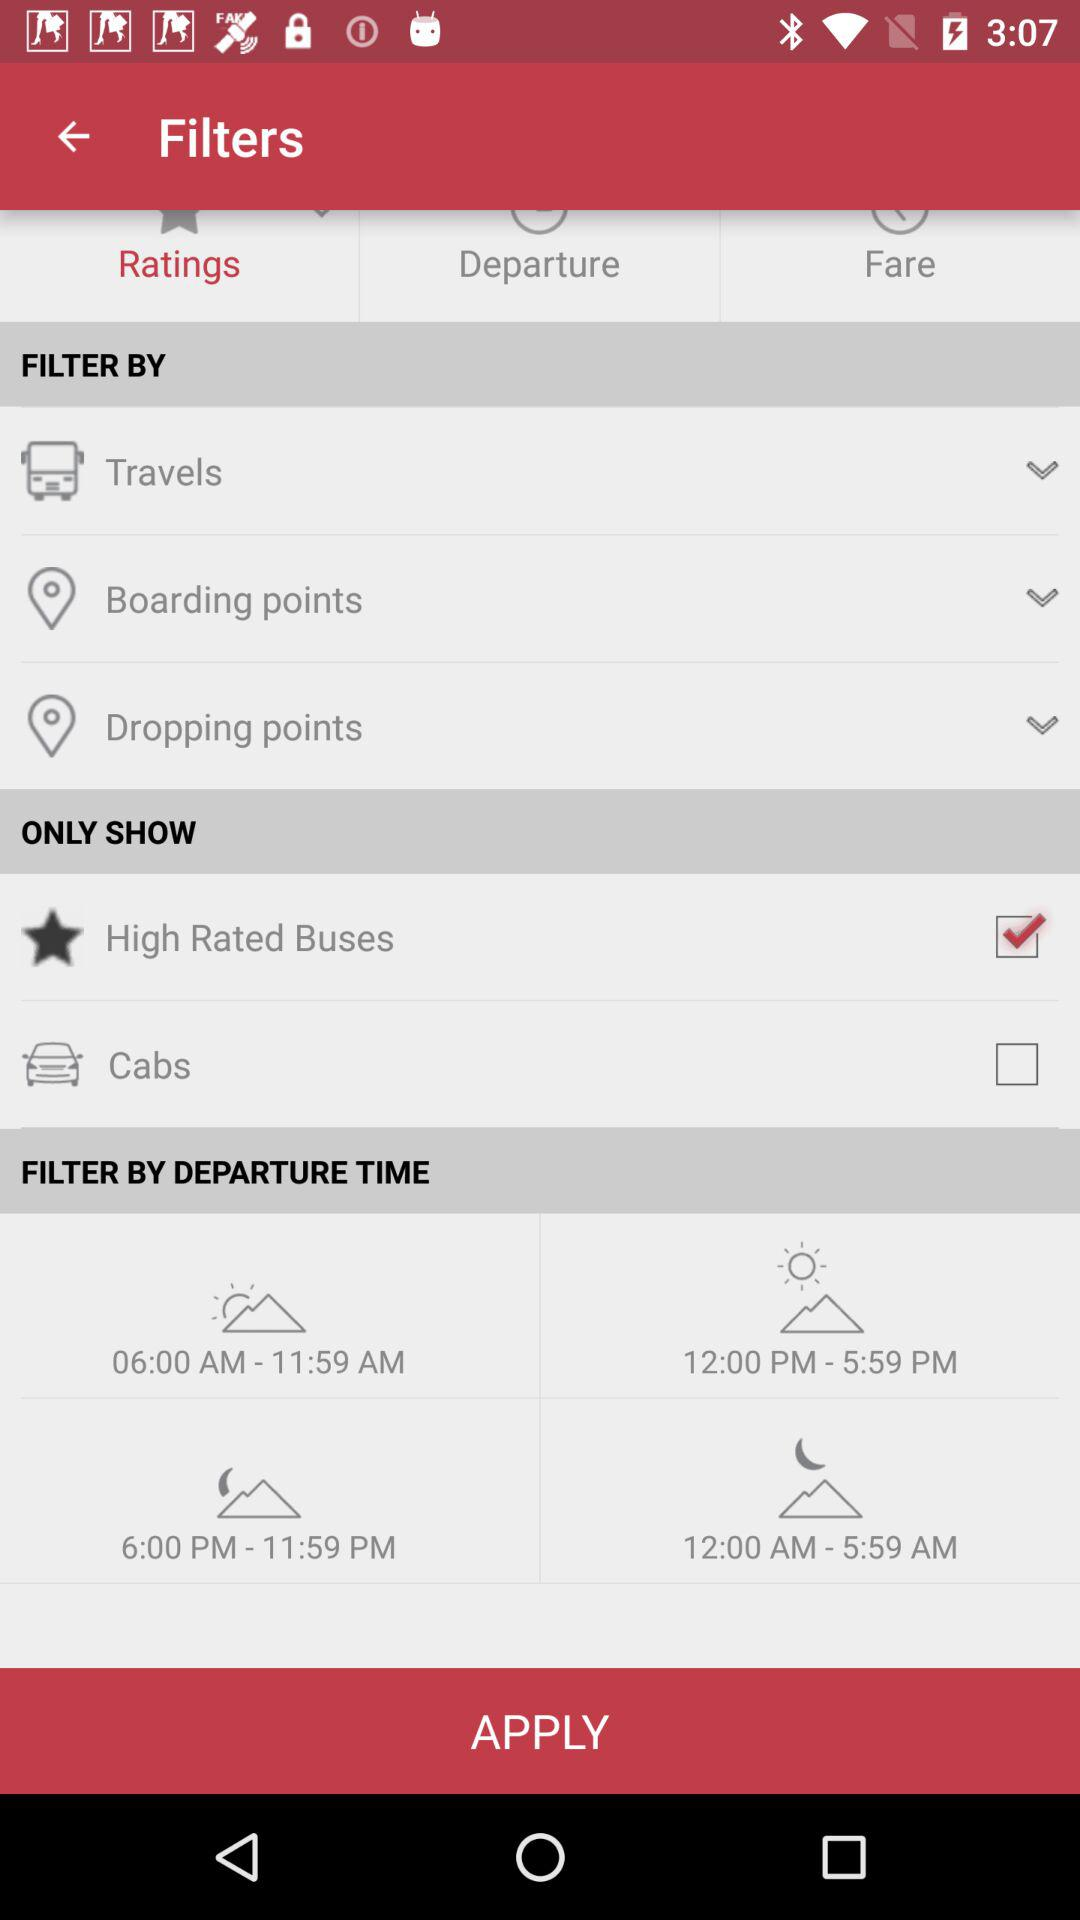What is the status of the "High Rated Buses"? The status is "on". 